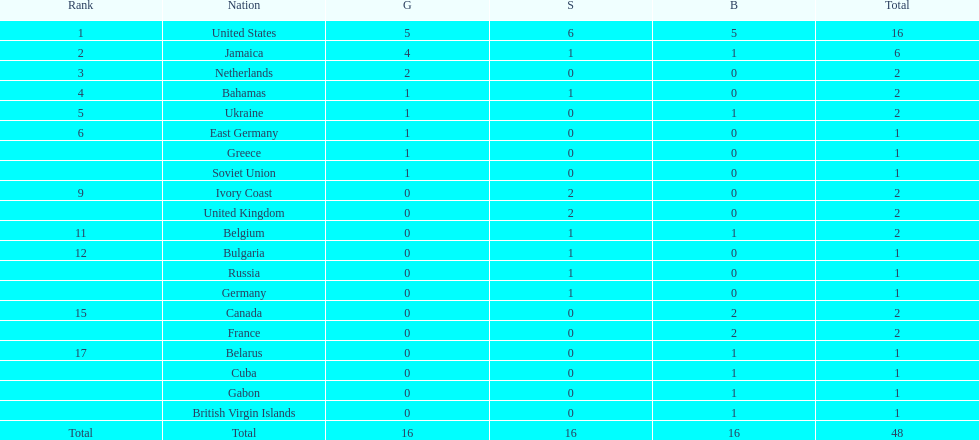How many nations received more medals than canada? 2. Can you give me this table as a dict? {'header': ['Rank', 'Nation', 'G', 'S', 'B', 'Total'], 'rows': [['1', 'United States', '5', '6', '5', '16'], ['2', 'Jamaica', '4', '1', '1', '6'], ['3', 'Netherlands', '2', '0', '0', '2'], ['4', 'Bahamas', '1', '1', '0', '2'], ['5', 'Ukraine', '1', '0', '1', '2'], ['6', 'East Germany', '1', '0', '0', '1'], ['', 'Greece', '1', '0', '0', '1'], ['', 'Soviet Union', '1', '0', '0', '1'], ['9', 'Ivory Coast', '0', '2', '0', '2'], ['', 'United Kingdom', '0', '2', '0', '2'], ['11', 'Belgium', '0', '1', '1', '2'], ['12', 'Bulgaria', '0', '1', '0', '1'], ['', 'Russia', '0', '1', '0', '1'], ['', 'Germany', '0', '1', '0', '1'], ['15', 'Canada', '0', '0', '2', '2'], ['', 'France', '0', '0', '2', '2'], ['17', 'Belarus', '0', '0', '1', '1'], ['', 'Cuba', '0', '0', '1', '1'], ['', 'Gabon', '0', '0', '1', '1'], ['', 'British Virgin Islands', '0', '0', '1', '1'], ['Total', 'Total', '16', '16', '16', '48']]} 